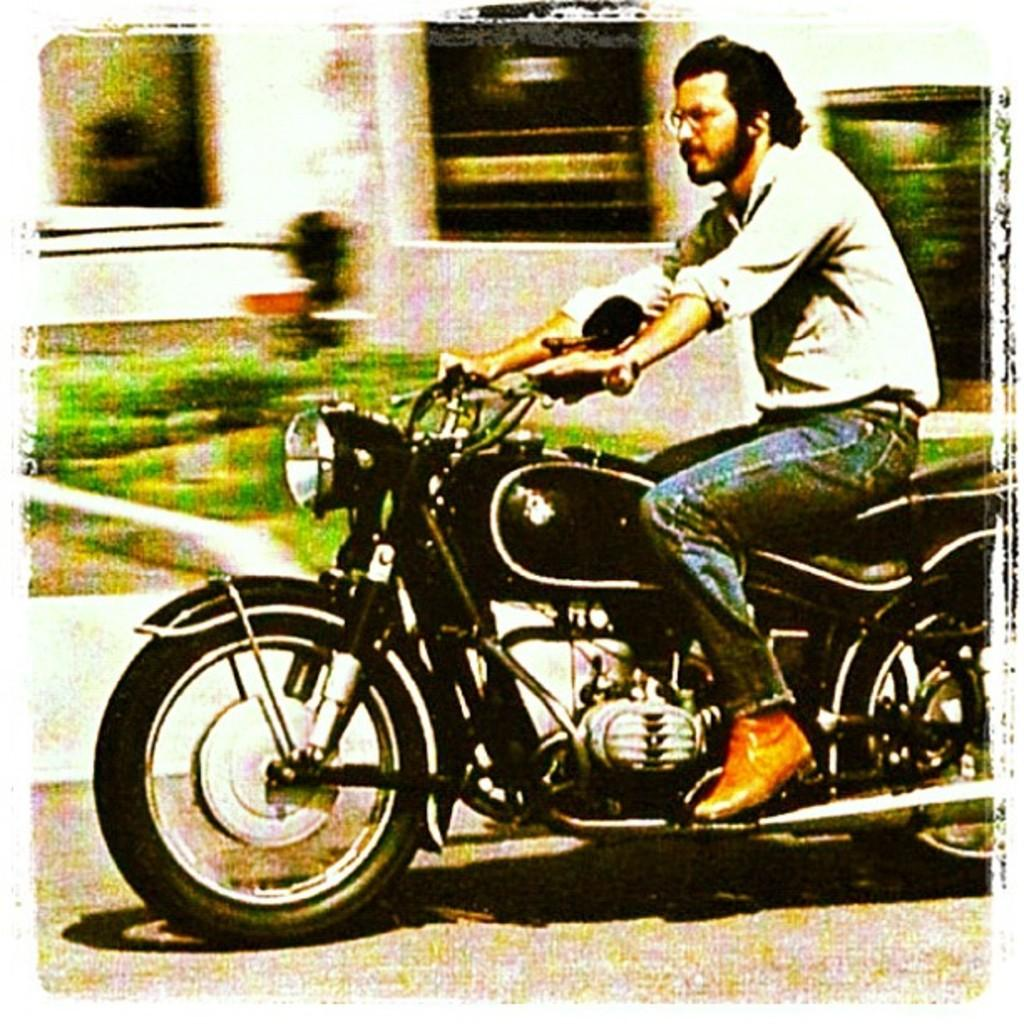What is the man in the image doing? The man is riding a bike in the image. How is the man positioned on the bike? The man is sitting on the bike. What can be seen in the background of the image? There are plants and a building in the background of the image. What type of machine is the man using to ride in the image? The man is not using a machine to ride in the image; he is riding a bike, which is a human-powered vehicle. How many dimes can be seen on the bike in the image? There are no dimes present on the bike or in the image. 